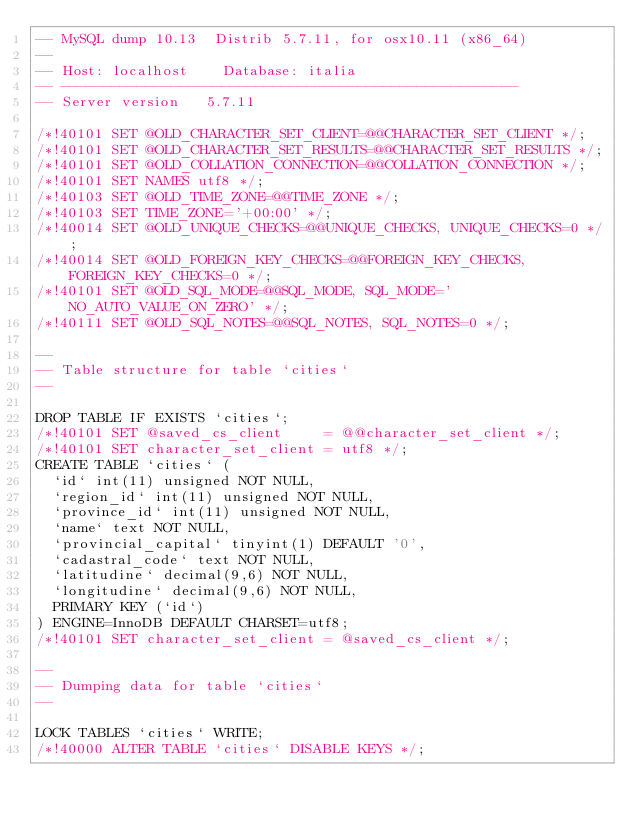<code> <loc_0><loc_0><loc_500><loc_500><_SQL_>-- MySQL dump 10.13  Distrib 5.7.11, for osx10.11 (x86_64)
--
-- Host: localhost    Database: italia
-- ------------------------------------------------------
-- Server version	5.7.11

/*!40101 SET @OLD_CHARACTER_SET_CLIENT=@@CHARACTER_SET_CLIENT */;
/*!40101 SET @OLD_CHARACTER_SET_RESULTS=@@CHARACTER_SET_RESULTS */;
/*!40101 SET @OLD_COLLATION_CONNECTION=@@COLLATION_CONNECTION */;
/*!40101 SET NAMES utf8 */;
/*!40103 SET @OLD_TIME_ZONE=@@TIME_ZONE */;
/*!40103 SET TIME_ZONE='+00:00' */;
/*!40014 SET @OLD_UNIQUE_CHECKS=@@UNIQUE_CHECKS, UNIQUE_CHECKS=0 */;
/*!40014 SET @OLD_FOREIGN_KEY_CHECKS=@@FOREIGN_KEY_CHECKS, FOREIGN_KEY_CHECKS=0 */;
/*!40101 SET @OLD_SQL_MODE=@@SQL_MODE, SQL_MODE='NO_AUTO_VALUE_ON_ZERO' */;
/*!40111 SET @OLD_SQL_NOTES=@@SQL_NOTES, SQL_NOTES=0 */;

--
-- Table structure for table `cities`
--

DROP TABLE IF EXISTS `cities`;
/*!40101 SET @saved_cs_client     = @@character_set_client */;
/*!40101 SET character_set_client = utf8 */;
CREATE TABLE `cities` (
  `id` int(11) unsigned NOT NULL,
  `region_id` int(11) unsigned NOT NULL,
  `province_id` int(11) unsigned NOT NULL,
  `name` text NOT NULL,
  `provincial_capital` tinyint(1) DEFAULT '0',
  `cadastral_code` text NOT NULL,
  `latitudine` decimal(9,6) NOT NULL,
  `longitudine` decimal(9,6) NOT NULL,
  PRIMARY KEY (`id`)
) ENGINE=InnoDB DEFAULT CHARSET=utf8;
/*!40101 SET character_set_client = @saved_cs_client */;

--
-- Dumping data for table `cities`
--

LOCK TABLES `cities` WRITE;
/*!40000 ALTER TABLE `cities` DISABLE KEYS */;</code> 